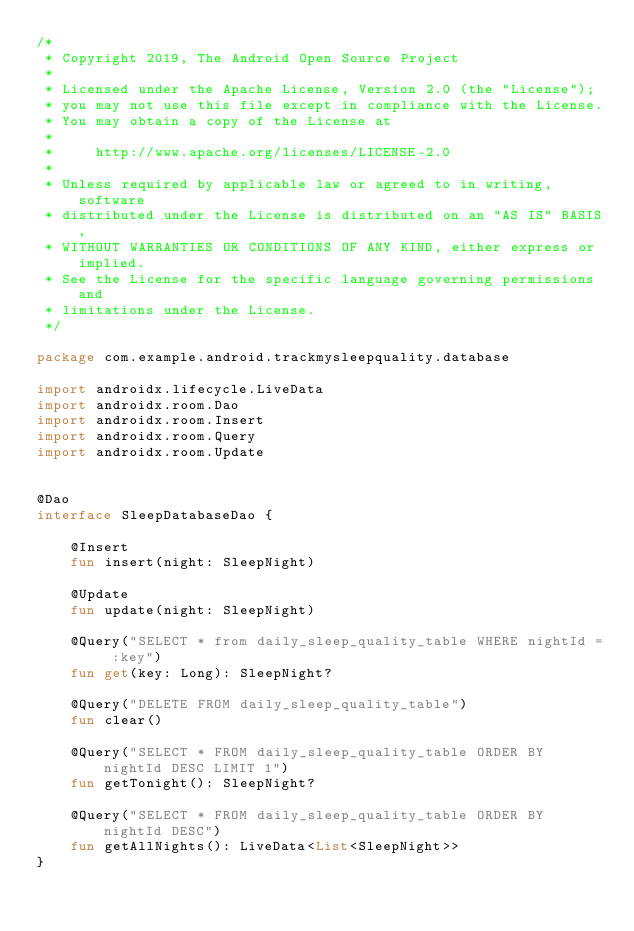<code> <loc_0><loc_0><loc_500><loc_500><_Kotlin_>/*
 * Copyright 2019, The Android Open Source Project
 *
 * Licensed under the Apache License, Version 2.0 (the "License");
 * you may not use this file except in compliance with the License.
 * You may obtain a copy of the License at
 *
 *     http://www.apache.org/licenses/LICENSE-2.0
 *
 * Unless required by applicable law or agreed to in writing, software
 * distributed under the License is distributed on an "AS IS" BASIS,
 * WITHOUT WARRANTIES OR CONDITIONS OF ANY KIND, either express or implied.
 * See the License for the specific language governing permissions and
 * limitations under the License.
 */

package com.example.android.trackmysleepquality.database

import androidx.lifecycle.LiveData
import androidx.room.Dao
import androidx.room.Insert
import androidx.room.Query
import androidx.room.Update


@Dao
interface SleepDatabaseDao {

    @Insert
    fun insert(night: SleepNight)

    @Update
    fun update(night: SleepNight)

    @Query("SELECT * from daily_sleep_quality_table WHERE nightId = :key")
    fun get(key: Long): SleepNight?

    @Query("DELETE FROM daily_sleep_quality_table")
    fun clear()

    @Query("SELECT * FROM daily_sleep_quality_table ORDER BY nightId DESC LIMIT 1")
    fun getTonight(): SleepNight?

    @Query("SELECT * FROM daily_sleep_quality_table ORDER BY nightId DESC")
    fun getAllNights(): LiveData<List<SleepNight>>
}



</code> 